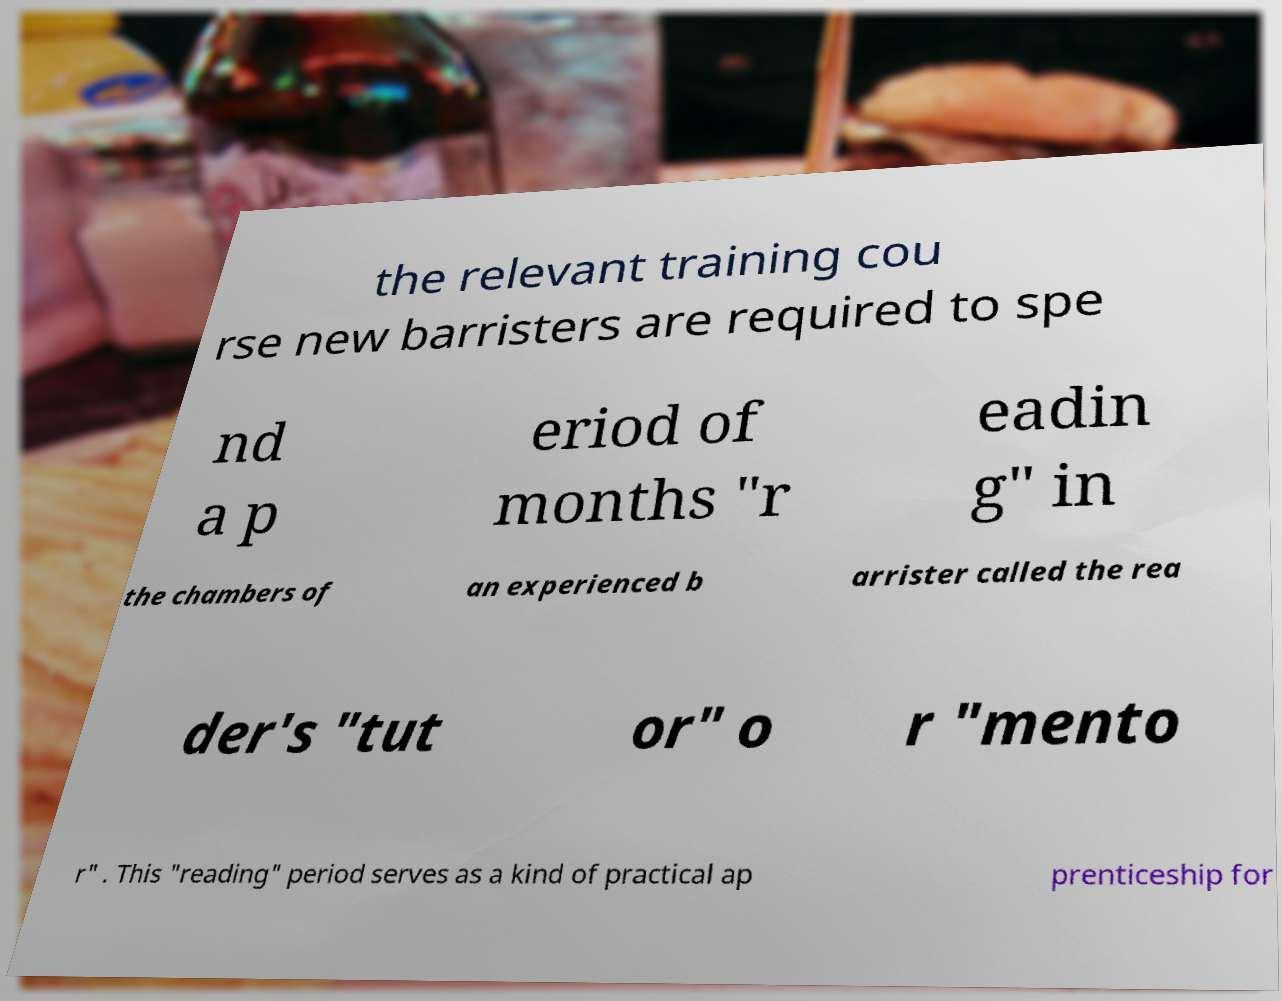Can you accurately transcribe the text from the provided image for me? the relevant training cou rse new barristers are required to spe nd a p eriod of months "r eadin g" in the chambers of an experienced b arrister called the rea der's "tut or" o r "mento r" . This "reading" period serves as a kind of practical ap prenticeship for 